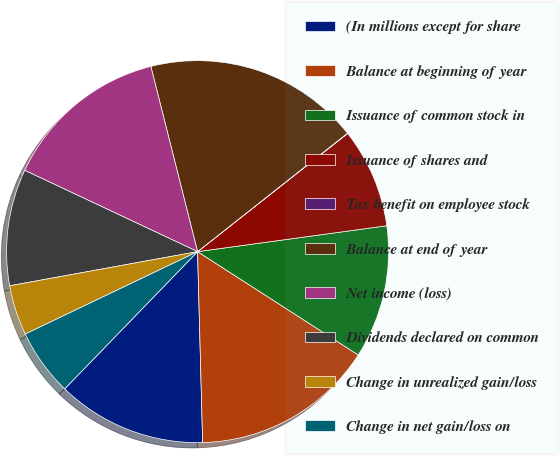<chart> <loc_0><loc_0><loc_500><loc_500><pie_chart><fcel>(In millions except for share<fcel>Balance at beginning of year<fcel>Issuance of common stock in<fcel>Issuance of shares and<fcel>Tax benefit on employee stock<fcel>Balance at end of year<fcel>Net income (loss)<fcel>Dividends declared on common<fcel>Change in unrealized gain/loss<fcel>Change in net gain/loss on<nl><fcel>12.67%<fcel>15.48%<fcel>11.26%<fcel>8.45%<fcel>0.03%<fcel>18.29%<fcel>14.07%<fcel>9.86%<fcel>4.24%<fcel>5.65%<nl></chart> 